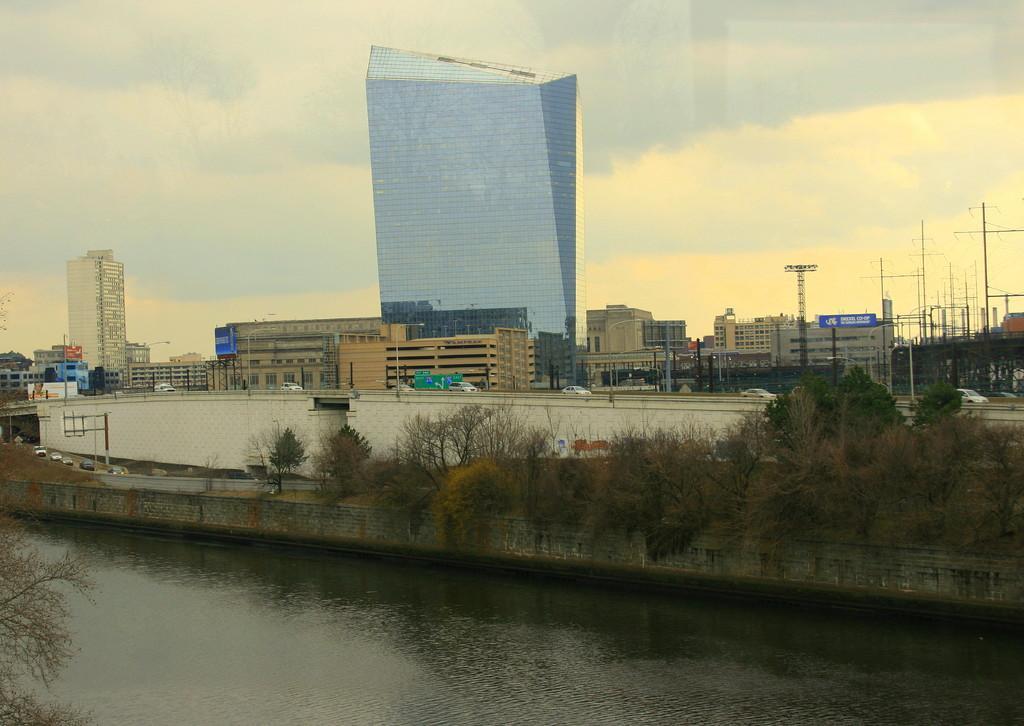Could you give a brief overview of what you see in this image? In this image I can see the water. To the side of the water there are many trees and the white wall. In the background I can see many buildings, vehicles, poles and boards. I can also see the clouds and sky in the back. 